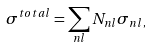<formula> <loc_0><loc_0><loc_500><loc_500>\sigma ^ { t o t a l } = \sum _ { n l } N _ { n l } \sigma _ { n l , }</formula> 